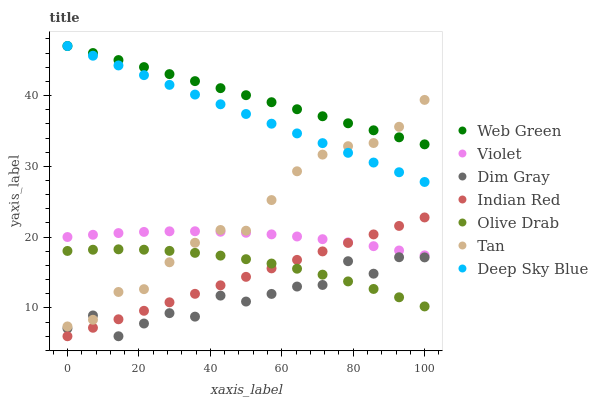Does Dim Gray have the minimum area under the curve?
Answer yes or no. Yes. Does Web Green have the maximum area under the curve?
Answer yes or no. Yes. Does Deep Sky Blue have the minimum area under the curve?
Answer yes or no. No. Does Deep Sky Blue have the maximum area under the curve?
Answer yes or no. No. Is Deep Sky Blue the smoothest?
Answer yes or no. Yes. Is Dim Gray the roughest?
Answer yes or no. Yes. Is Web Green the smoothest?
Answer yes or no. No. Is Web Green the roughest?
Answer yes or no. No. Does Indian Red have the lowest value?
Answer yes or no. Yes. Does Deep Sky Blue have the lowest value?
Answer yes or no. No. Does Web Green have the highest value?
Answer yes or no. Yes. Does Indian Red have the highest value?
Answer yes or no. No. Is Dim Gray less than Violet?
Answer yes or no. Yes. Is Deep Sky Blue greater than Olive Drab?
Answer yes or no. Yes. Does Deep Sky Blue intersect Web Green?
Answer yes or no. Yes. Is Deep Sky Blue less than Web Green?
Answer yes or no. No. Is Deep Sky Blue greater than Web Green?
Answer yes or no. No. Does Dim Gray intersect Violet?
Answer yes or no. No. 